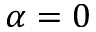<formula> <loc_0><loc_0><loc_500><loc_500>\alpha = 0</formula> 